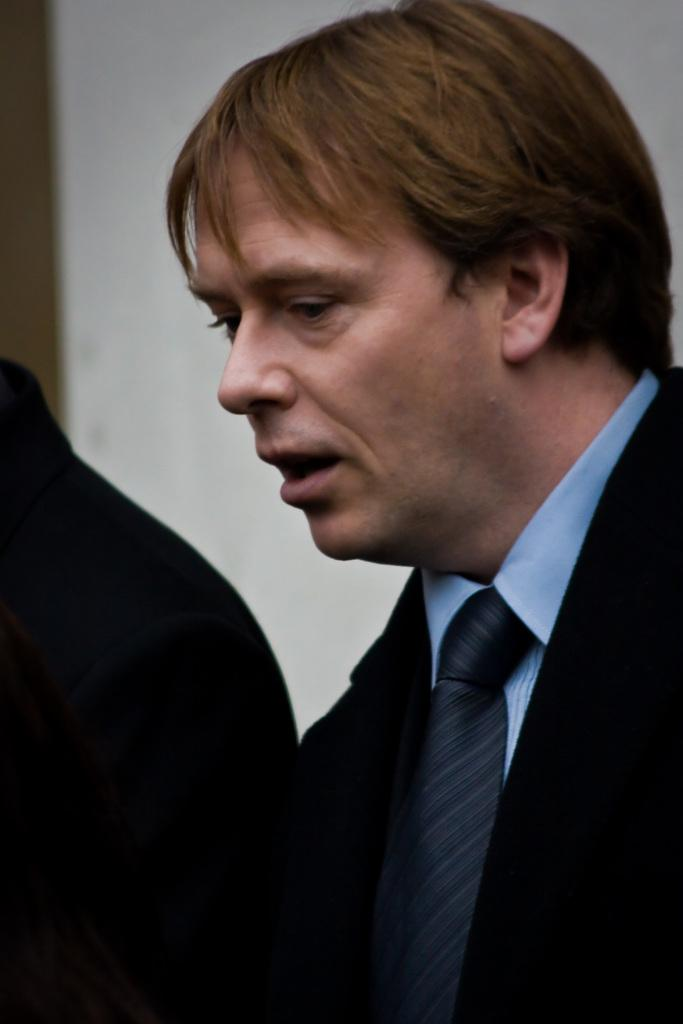Who or what is present in the image? There are people in the image. What can be observed about the attire of the people in the image? The people are wearing different color dresses. What is the color of the background in the image? The background of the image is white. What type of caption is written on the badge of the maid in the image? There is no maid or badge present in the image. 